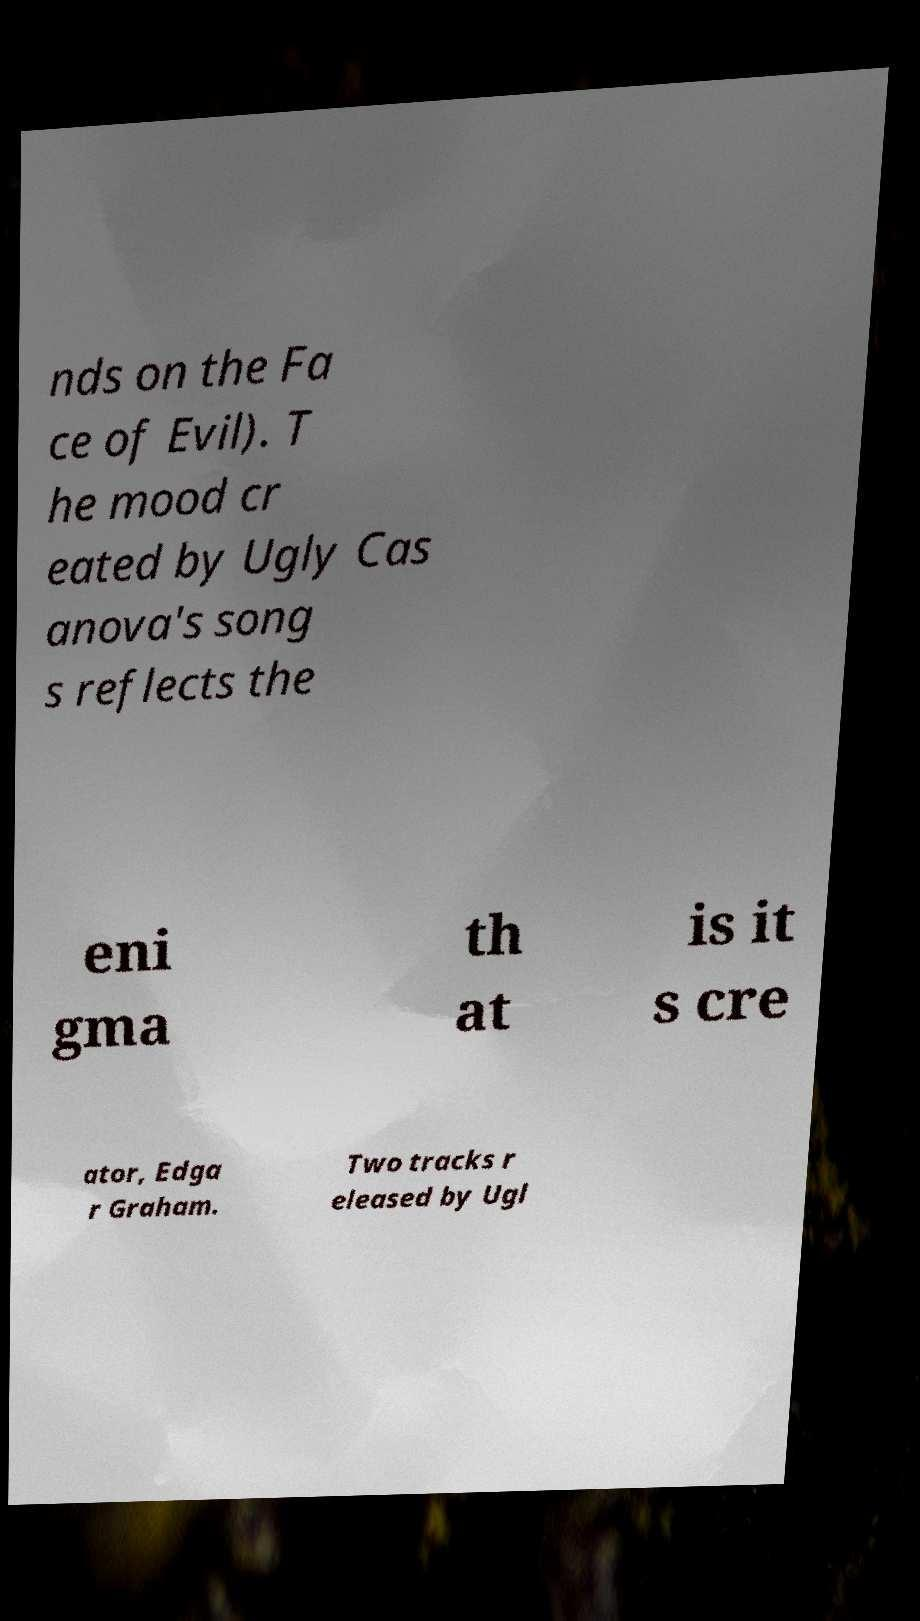Can you accurately transcribe the text from the provided image for me? nds on the Fa ce of Evil). T he mood cr eated by Ugly Cas anova's song s reflects the eni gma th at is it s cre ator, Edga r Graham. Two tracks r eleased by Ugl 